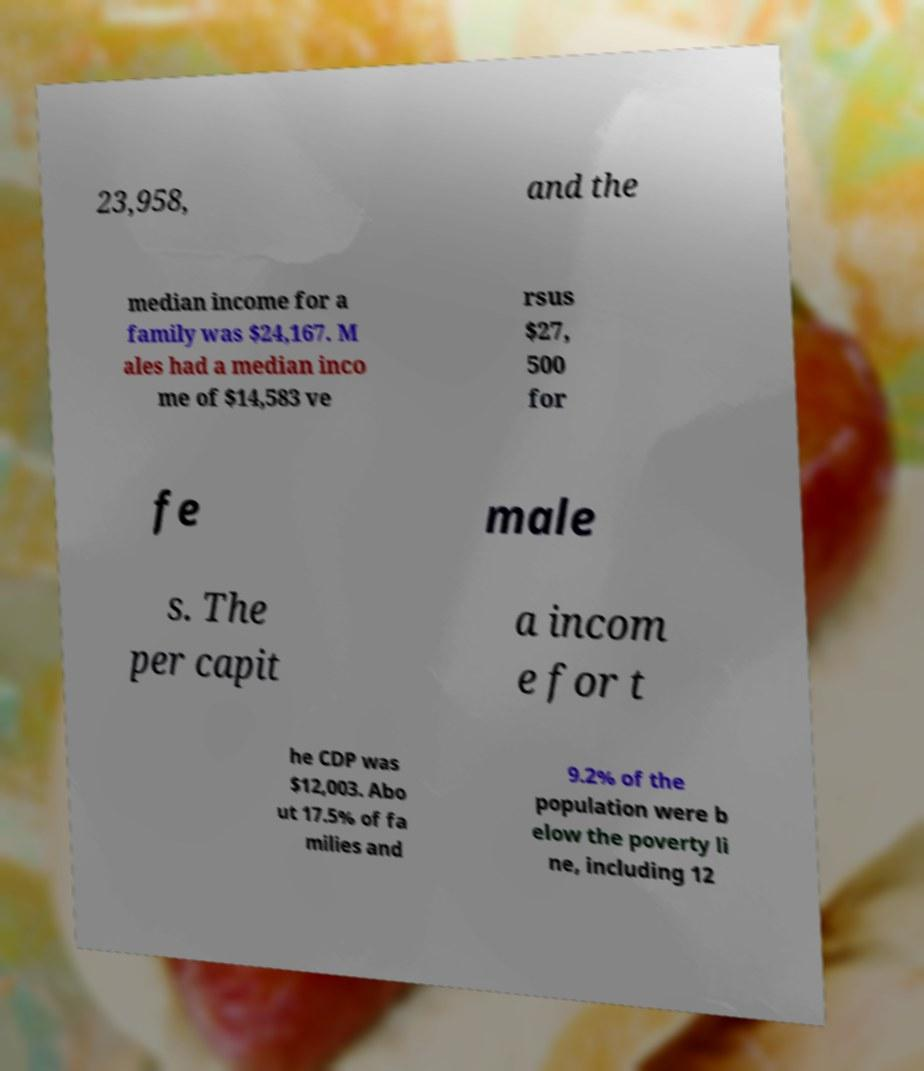What messages or text are displayed in this image? I need them in a readable, typed format. 23,958, and the median income for a family was $24,167. M ales had a median inco me of $14,583 ve rsus $27, 500 for fe male s. The per capit a incom e for t he CDP was $12,003. Abo ut 17.5% of fa milies and 9.2% of the population were b elow the poverty li ne, including 12 